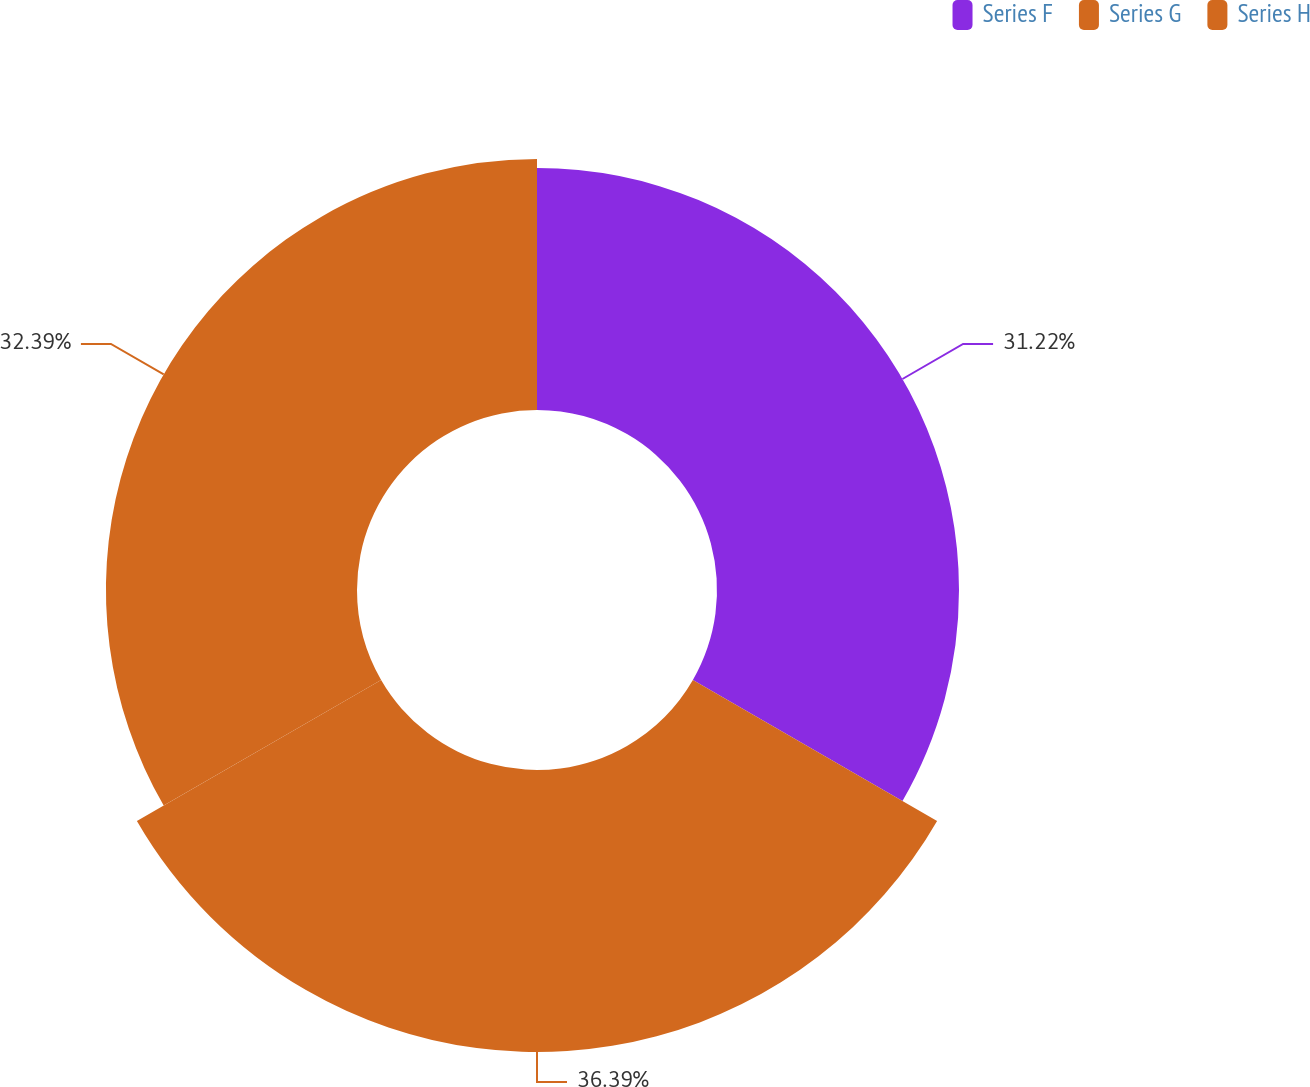<chart> <loc_0><loc_0><loc_500><loc_500><pie_chart><fcel>Series F<fcel>Series G<fcel>Series H<nl><fcel>31.22%<fcel>36.38%<fcel>32.39%<nl></chart> 